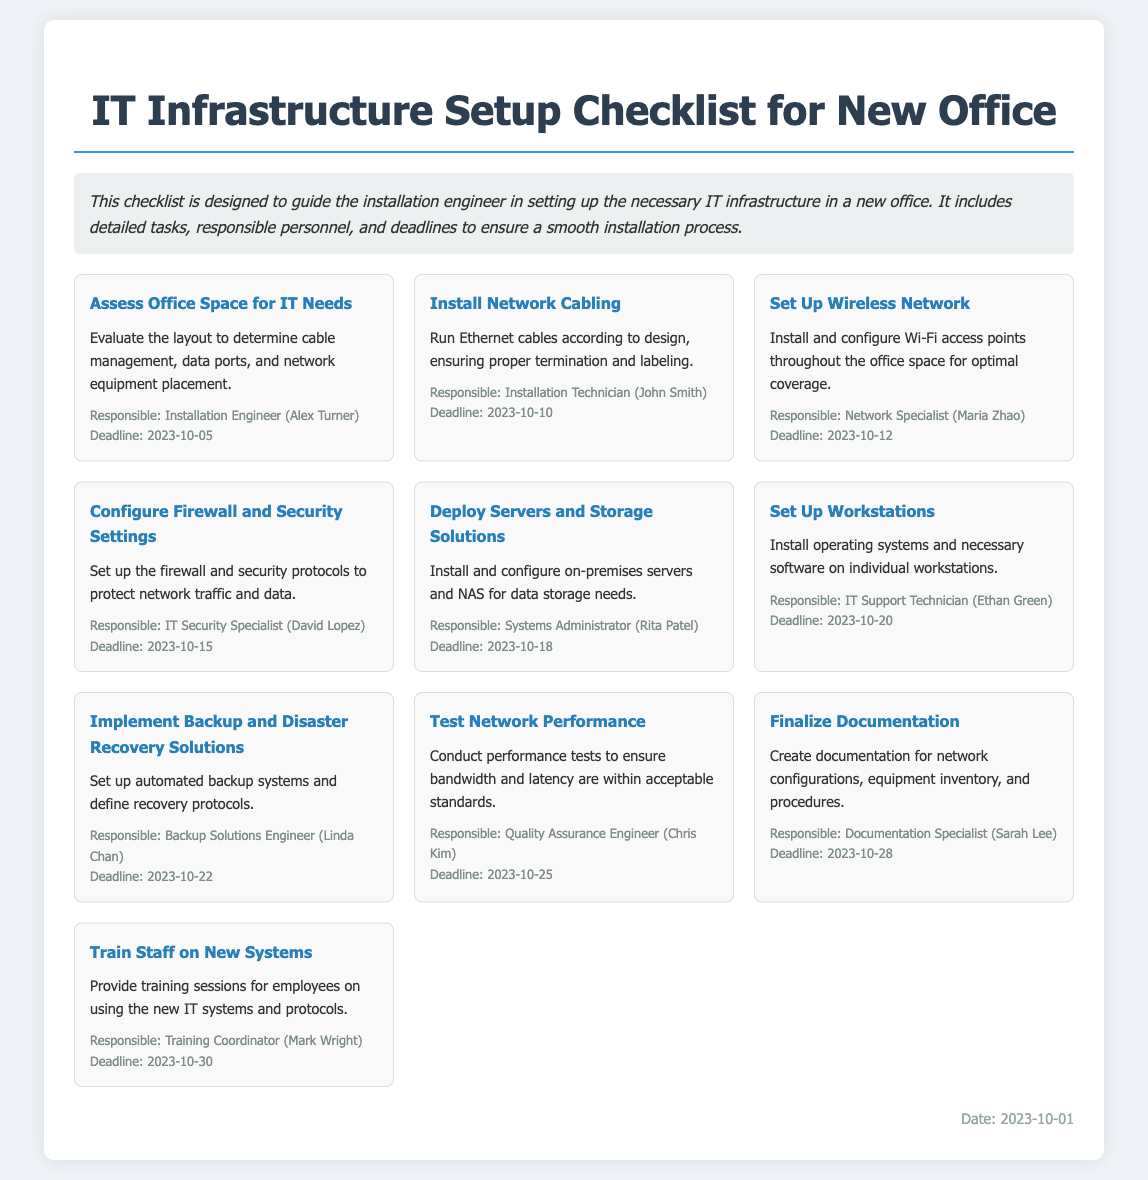What is the title of the document? The title of the document is displayed prominently at the top and is "IT Infrastructure Setup Checklist for New Office."
Answer: IT Infrastructure Setup Checklist for New Office Who is responsible for assessing the office space for IT needs? The task card mentions "Installation Engineer (Alex Turner)" as the responsible personnel for this task.
Answer: Installation Engineer (Alex Turner) What is the deadline for installing network cabling? The deadline is specified in the task card for installing network cabling, which is "2023-10-10."
Answer: 2023-10-10 How many days do we have for configuring the firewall and security settings? The task mentions "2023-10-15" as the deadline, and the current date is "2023-10-01," indicating we have 14 days.
Answer: 14 days Which task is scheduled for 2023-10-30? The task card shows "Train Staff on New Systems" is scheduled on this date.
Answer: Train Staff on New Systems What is the main focus of the document? The document is designed to guide the installation engineer in setting up necessary IT infrastructure.
Answer: Guide the installation engineer Who is responsible for testing network performance? The task card specifies "Quality Assurance Engineer (Chris Kim)" for this responsibility.
Answer: Quality Assurance Engineer (Chris Kim) What type of documentation will be finalized? The task mentions that the documentation includes "network configurations, equipment inventory, and procedures."
Answer: network configurations, equipment inventory, and procedures When should the backup and disaster recovery solutions be implemented? The deadline for this task is mentioned as "2023-10-22."
Answer: 2023-10-22 